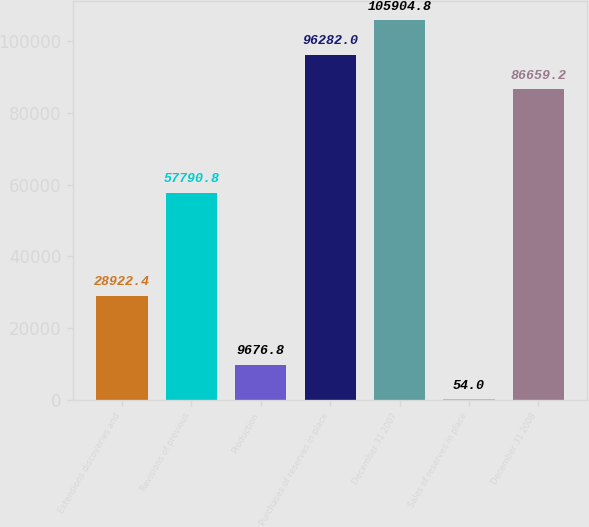<chart> <loc_0><loc_0><loc_500><loc_500><bar_chart><fcel>Extensions discoveries and<fcel>Revisions of previous<fcel>Production<fcel>Purchases of reserves in place<fcel>December 31 2007<fcel>Sales of reserves in place<fcel>December 31 2008<nl><fcel>28922.4<fcel>57790.8<fcel>9676.8<fcel>96282<fcel>105905<fcel>54<fcel>86659.2<nl></chart> 